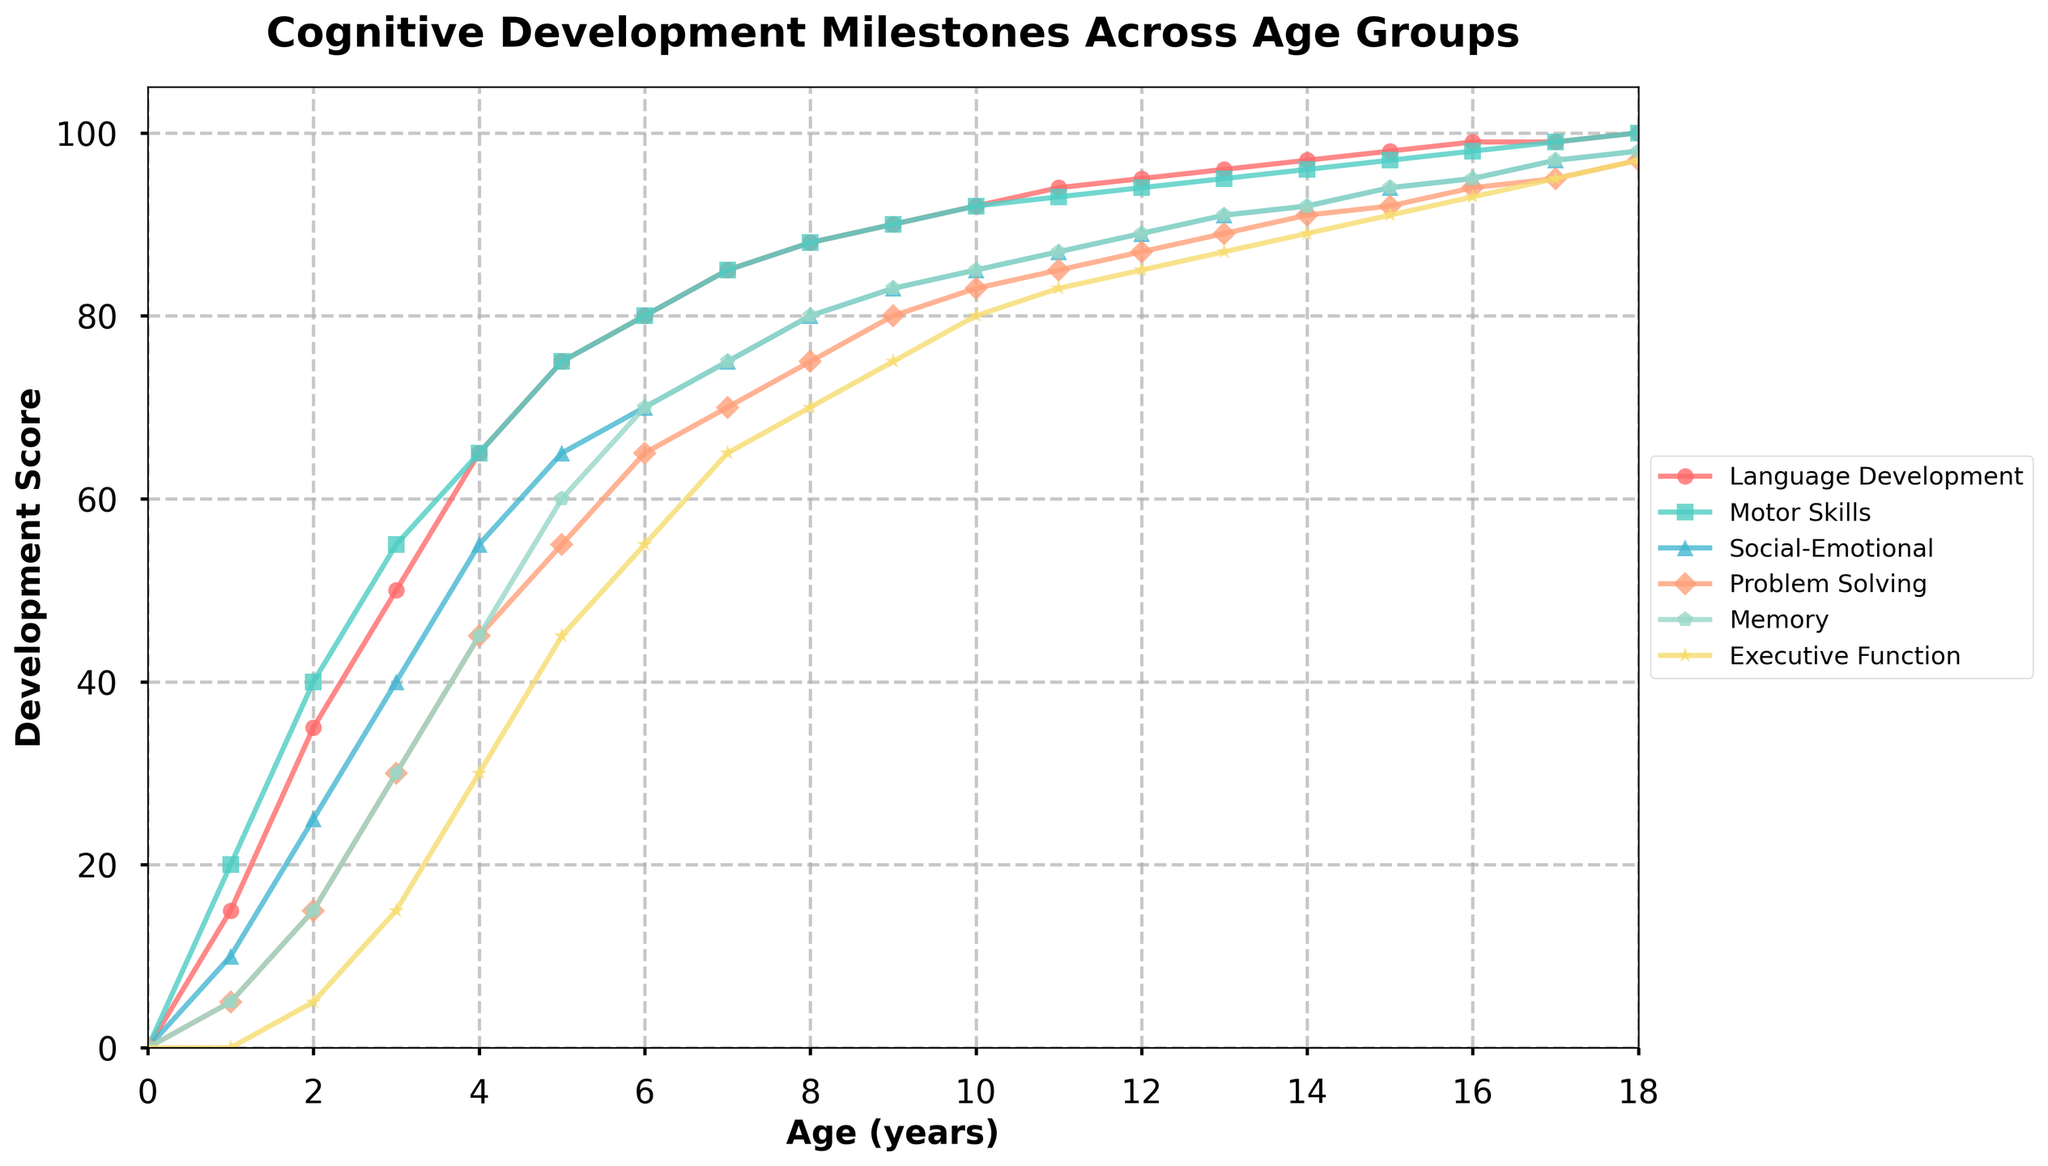What age does Executive Function development start showing visible progress? At age 1, the development score for Executive Function is 0, and by age 2, it progresses to 5. The first visible progress starts at age 2.
Answer: Age 2 Which cognitive domain shows the highest development score at age 5? At age 5, the development scores are: Language Development (75), Motor Skills (75), Social-Emotional (65), Problem Solving (55), Memory (60), and Executive Function (45). The highest score is in both Language Development and Motor Skills.
Answer: Language Development and Motor Skills At what age do all cognitive domains first reach at least 80 in development score? By inspecting each line, the earliest age at which all domains reach at least 80 is at age 9.
Answer: Age 9 Which cognitive domain has the steepest increase between ages 0 and 3? To find the steepest increase, calculate the difference between ages 0 and 3 for each domain:
Language Development: 50 - 0 = 50
Motor Skills: 55 - 0 = 55
Social-Emotional: 40 - 0 = 40
Problem Solving: 30 - 0 = 30
Memory: 30 - 0 = 30
Executive Function: 15 - 0 = 15. Motor Skills have the steepest increase.
Answer: Motor Skills What color represents the Problem Solving domain in the chart? According to the provided code, the Problem Solving domain is represented by the fourth color in the list, which corresponds to orange.
Answer: Orange Compare the development scores of Social-Emotional skills and Memory at age 14. Which is higher? At age 14, the development scores are Social-Emotional (92) and Memory (92). They are equal.
Answer: Equal What is the total development score for Memory from age 0 to 5? Summing up the scores for Memory from age 0 to 5: 0 (Age 0) + 5 (Age 1) + 15 (Age 2) + 30 (Age 3) + 45 (Age 4) + 60 (Age 5) = 155
Answer: 155 Which cognitive domain reaches a development score of 100 first, and at what age? By inspecting each cognitive domain trajectory, Language Development reaches a score of 100 at age 18.
Answer: Language Development, Age 18 What is the average development score for Executive Function across ages 1 to 5? Summing the Executive Function scores for ages 1 to 5: 0 (Age 1) + 5 (Age 2) + 15 (Age 3) + 30 (Age 4) + 45 (Age 5) = 95 and then dividing by 5 gives an average of 95 / 5 = 19
Answer: 19 